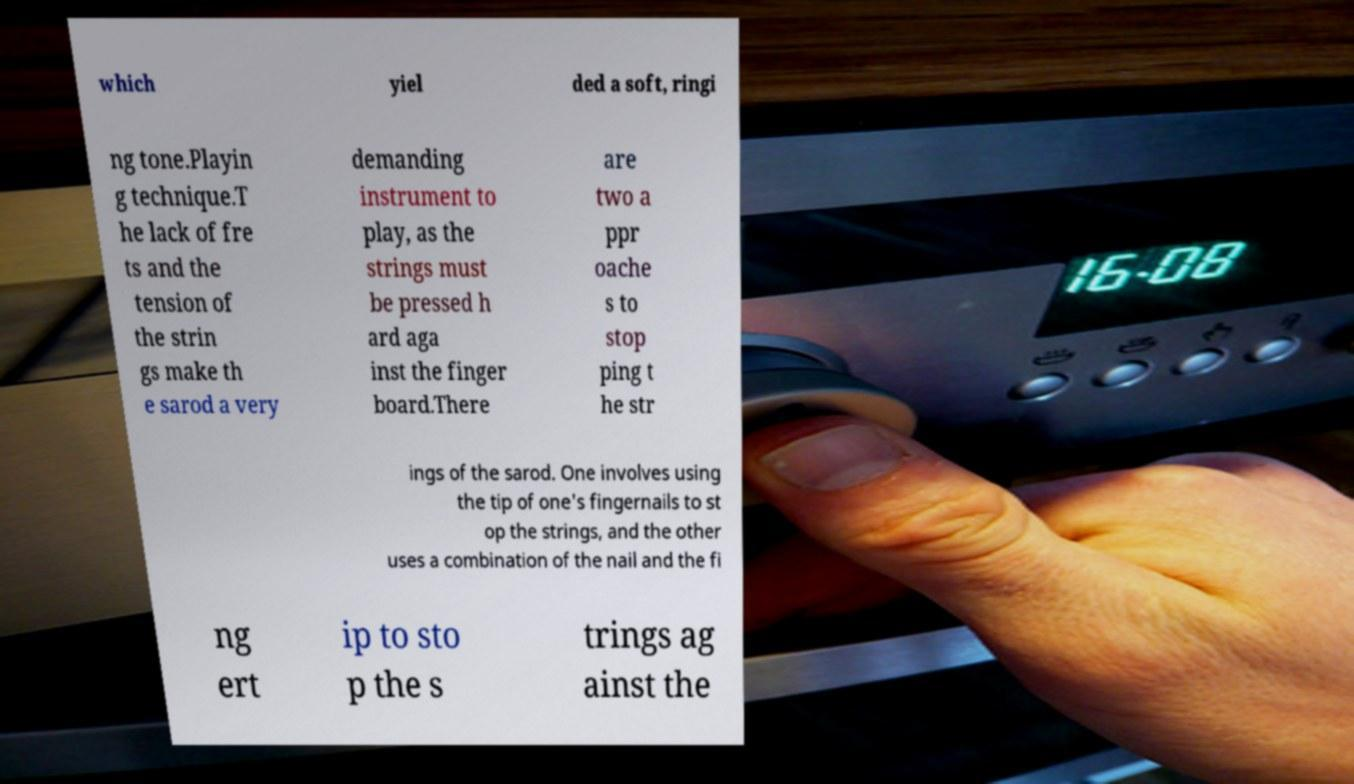Please read and relay the text visible in this image. What does it say? which yiel ded a soft, ringi ng tone.Playin g technique.T he lack of fre ts and the tension of the strin gs make th e sarod a very demanding instrument to play, as the strings must be pressed h ard aga inst the finger board.There are two a ppr oache s to stop ping t he str ings of the sarod. One involves using the tip of one's fingernails to st op the strings, and the other uses a combination of the nail and the fi ng ert ip to sto p the s trings ag ainst the 